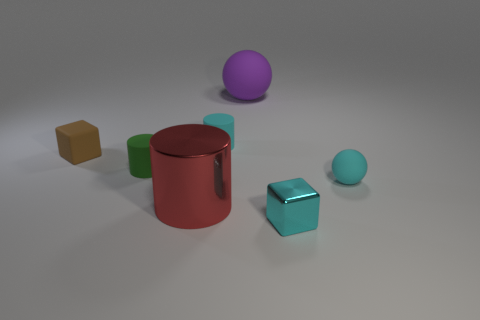Do the small rubber sphere and the metal block have the same color?
Offer a very short reply. Yes. What size is the brown object that is the same material as the cyan cylinder?
Your answer should be compact. Small. Are there more green cylinders that are behind the tiny rubber cube than large things in front of the small cyan cylinder?
Give a very brief answer. No. Are there any large red shiny things of the same shape as the green matte object?
Make the answer very short. Yes. Do the cube that is in front of the shiny cylinder and the brown rubber object have the same size?
Your answer should be very brief. Yes. Is there a tiny green cylinder?
Make the answer very short. Yes. What number of things are either shiny things that are on the right side of the big red metal cylinder or green cylinders?
Your answer should be very brief. 2. There is a small shiny cube; is its color the same as the matte thing that is in front of the tiny green matte object?
Your answer should be very brief. Yes. Are there any brown rubber blocks that have the same size as the metal block?
Your answer should be very brief. Yes. There is a red cylinder that is behind the small cube that is right of the big red metallic cylinder; what is its material?
Give a very brief answer. Metal. 